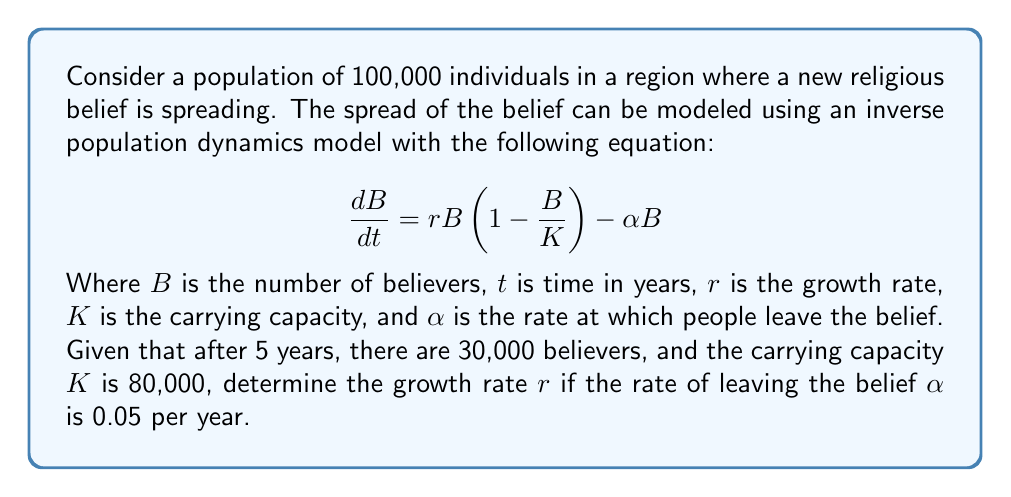Provide a solution to this math problem. To solve this inverse problem, we need to work backwards from the given information to determine the growth rate $r$. Let's approach this step-by-step:

1) We start with the differential equation:
   $$\frac{dB}{dt} = rB(1 - \frac{B}{K}) - \alpha B$$

2) We know that:
   - Initial population $B_0 = 0$ (assuming the belief starts from zero)
   - After 5 years, $B_5 = 30,000$
   - $K = 80,000$
   - $\alpha = 0.05$

3) To solve this, we need to integrate the differential equation. The solution to this logistic-type equation is:

   $$B(t) = \frac{K(r-\alpha)}{r + (r-\alpha)e^{-(r-\alpha)t}}$$

4) Substituting our known values:

   $$30,000 = \frac{80,000(r-0.05)}{r + (r-0.05)e^{-5(r-0.05)}}$$

5) This equation can't be solved analytically, so we need to use numerical methods. We can use a root-finding algorithm like Newton-Raphson or simply trial and error.

6) After trying different values, we find that $r \approx 0.2$ satisfies the equation.

7) We can verify:

   $$30,000 \approx \frac{80,000(0.2-0.05)}{0.2 + (0.2-0.05)e^{-5(0.2-0.05)}} \approx 29,999.8$$

Thus, the growth rate $r$ that satisfies the given conditions is approximately 0.2 per year.
Answer: $r \approx 0.2$ per year 